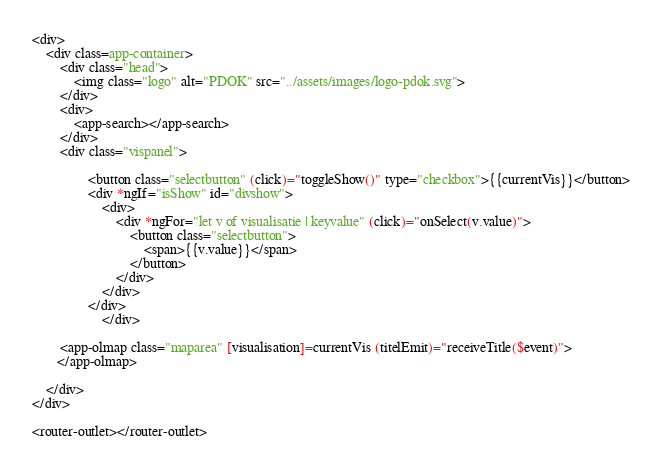<code> <loc_0><loc_0><loc_500><loc_500><_HTML_><div>
    <div class=app-container>
        <div class="head">
            <img class="logo" alt="PDOK" src="../assets/images/logo-pdok.svg">
        </div>
        <div>
            <app-search></app-search>
        </div>
        <div class="vispanel">
            
                <button class="selectbutton" (click)="toggleShow()" type="checkbox">{{currentVis}}</button>
                <div *ngIf="isShow" id="divshow">
                    <div>
                        <div *ngFor="let v of visualisatie | keyvalue" (click)="onSelect(v.value)">
                            <button class="selectbutton">
                                <span>{{v.value}}</span>
                            </button>
                        </div>
                    </div>
                </div>
                    </div>

        <app-olmap class="maparea" [visualisation]=currentVis (titelEmit)="receiveTitle($event)">
       </app-olmap>

    </div>
</div>

<router-outlet></router-outlet></code> 